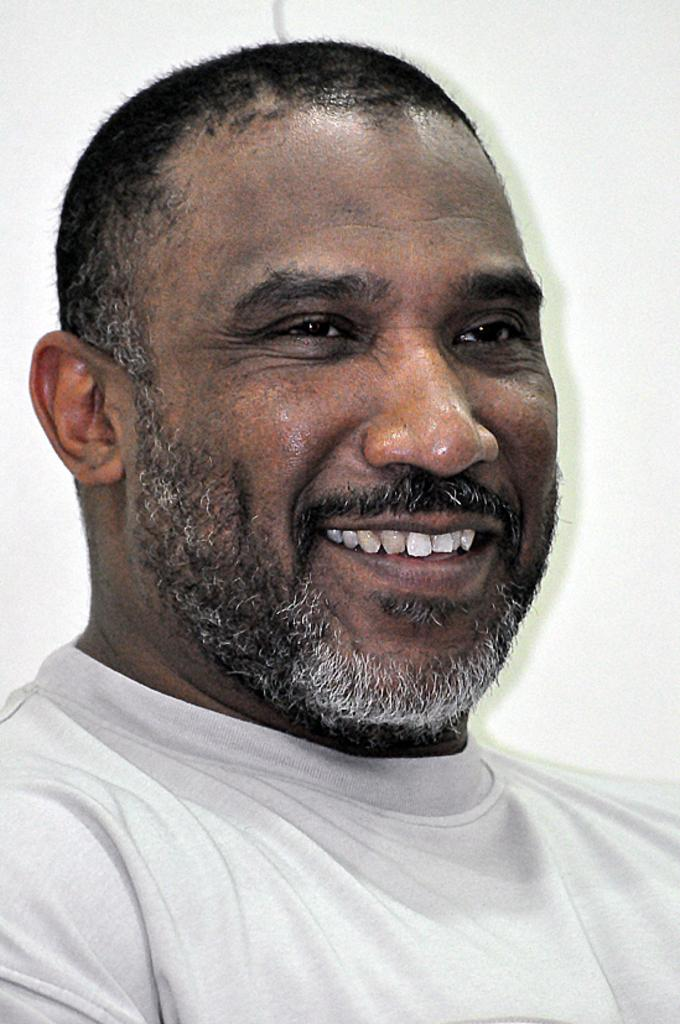Who is present in the image? There is a man in the image. What can be seen in the background of the image? There is a wall visible in the image. What instrument is the man playing in the image? There is no instrument present in the image; the man is not shown playing any instrument. 